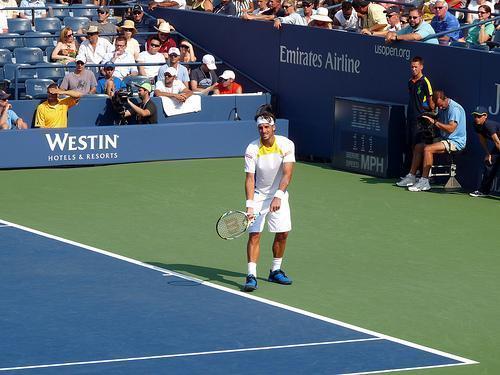How many sponsors are there?
Give a very brief answer. 3. How many tennis players can be seen in the picture?
Give a very brief answer. 1. 